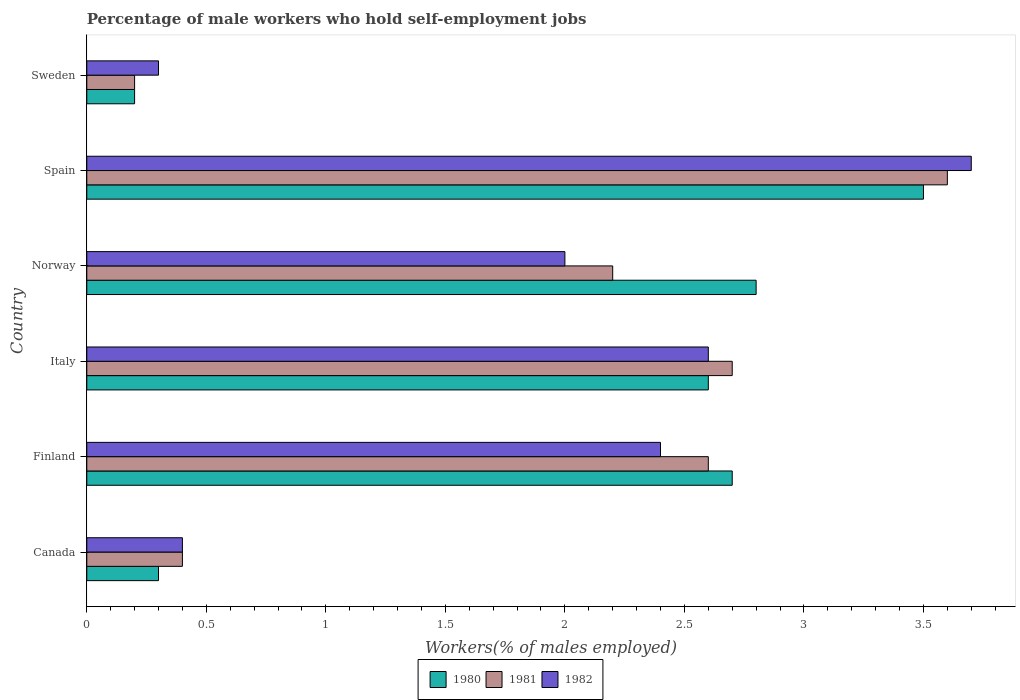How many different coloured bars are there?
Your answer should be compact. 3. How many groups of bars are there?
Give a very brief answer. 6. Are the number of bars per tick equal to the number of legend labels?
Your answer should be very brief. Yes. How many bars are there on the 5th tick from the top?
Make the answer very short. 3. How many bars are there on the 2nd tick from the bottom?
Make the answer very short. 3. In how many cases, is the number of bars for a given country not equal to the number of legend labels?
Provide a succinct answer. 0. What is the percentage of self-employed male workers in 1981 in Norway?
Make the answer very short. 2.2. Across all countries, what is the minimum percentage of self-employed male workers in 1982?
Offer a very short reply. 0.3. In which country was the percentage of self-employed male workers in 1981 maximum?
Give a very brief answer. Spain. What is the total percentage of self-employed male workers in 1981 in the graph?
Ensure brevity in your answer.  11.7. What is the difference between the percentage of self-employed male workers in 1980 in Finland and that in Italy?
Your response must be concise. 0.1. What is the difference between the percentage of self-employed male workers in 1980 in Spain and the percentage of self-employed male workers in 1981 in Finland?
Give a very brief answer. 0.9. What is the average percentage of self-employed male workers in 1982 per country?
Ensure brevity in your answer.  1.9. What is the ratio of the percentage of self-employed male workers in 1980 in Italy to that in Spain?
Keep it short and to the point. 0.74. Is the percentage of self-employed male workers in 1982 in Canada less than that in Sweden?
Offer a very short reply. No. What is the difference between the highest and the second highest percentage of self-employed male workers in 1981?
Your answer should be compact. 0.9. What is the difference between the highest and the lowest percentage of self-employed male workers in 1980?
Provide a succinct answer. 3.3. In how many countries, is the percentage of self-employed male workers in 1981 greater than the average percentage of self-employed male workers in 1981 taken over all countries?
Provide a succinct answer. 4. Is the sum of the percentage of self-employed male workers in 1982 in Spain and Sweden greater than the maximum percentage of self-employed male workers in 1980 across all countries?
Provide a succinct answer. Yes. What does the 3rd bar from the top in Canada represents?
Your answer should be very brief. 1980. What does the 3rd bar from the bottom in Italy represents?
Your answer should be compact. 1982. Is it the case that in every country, the sum of the percentage of self-employed male workers in 1980 and percentage of self-employed male workers in 1981 is greater than the percentage of self-employed male workers in 1982?
Make the answer very short. Yes. How many bars are there?
Offer a very short reply. 18. Does the graph contain grids?
Your answer should be compact. No. How are the legend labels stacked?
Make the answer very short. Horizontal. What is the title of the graph?
Provide a short and direct response. Percentage of male workers who hold self-employment jobs. What is the label or title of the X-axis?
Provide a short and direct response. Workers(% of males employed). What is the Workers(% of males employed) in 1980 in Canada?
Your response must be concise. 0.3. What is the Workers(% of males employed) in 1981 in Canada?
Keep it short and to the point. 0.4. What is the Workers(% of males employed) in 1982 in Canada?
Make the answer very short. 0.4. What is the Workers(% of males employed) of 1980 in Finland?
Keep it short and to the point. 2.7. What is the Workers(% of males employed) of 1981 in Finland?
Your answer should be very brief. 2.6. What is the Workers(% of males employed) in 1982 in Finland?
Ensure brevity in your answer.  2.4. What is the Workers(% of males employed) in 1980 in Italy?
Offer a terse response. 2.6. What is the Workers(% of males employed) in 1981 in Italy?
Your response must be concise. 2.7. What is the Workers(% of males employed) in 1982 in Italy?
Offer a very short reply. 2.6. What is the Workers(% of males employed) in 1980 in Norway?
Provide a succinct answer. 2.8. What is the Workers(% of males employed) of 1981 in Norway?
Offer a terse response. 2.2. What is the Workers(% of males employed) of 1981 in Spain?
Keep it short and to the point. 3.6. What is the Workers(% of males employed) in 1982 in Spain?
Make the answer very short. 3.7. What is the Workers(% of males employed) in 1980 in Sweden?
Offer a terse response. 0.2. What is the Workers(% of males employed) of 1981 in Sweden?
Ensure brevity in your answer.  0.2. What is the Workers(% of males employed) of 1982 in Sweden?
Your answer should be very brief. 0.3. Across all countries, what is the maximum Workers(% of males employed) in 1981?
Provide a short and direct response. 3.6. Across all countries, what is the maximum Workers(% of males employed) in 1982?
Your response must be concise. 3.7. Across all countries, what is the minimum Workers(% of males employed) of 1980?
Your answer should be compact. 0.2. Across all countries, what is the minimum Workers(% of males employed) of 1981?
Make the answer very short. 0.2. Across all countries, what is the minimum Workers(% of males employed) in 1982?
Provide a short and direct response. 0.3. What is the total Workers(% of males employed) in 1980 in the graph?
Offer a terse response. 12.1. What is the difference between the Workers(% of males employed) of 1981 in Canada and that in Finland?
Your response must be concise. -2.2. What is the difference between the Workers(% of males employed) of 1981 in Canada and that in Norway?
Your response must be concise. -1.8. What is the difference between the Workers(% of males employed) of 1982 in Canada and that in Norway?
Keep it short and to the point. -1.6. What is the difference between the Workers(% of males employed) of 1980 in Canada and that in Spain?
Ensure brevity in your answer.  -3.2. What is the difference between the Workers(% of males employed) in 1981 in Canada and that in Spain?
Your response must be concise. -3.2. What is the difference between the Workers(% of males employed) of 1982 in Canada and that in Spain?
Ensure brevity in your answer.  -3.3. What is the difference between the Workers(% of males employed) of 1980 in Canada and that in Sweden?
Your answer should be very brief. 0.1. What is the difference between the Workers(% of males employed) of 1982 in Canada and that in Sweden?
Offer a terse response. 0.1. What is the difference between the Workers(% of males employed) of 1980 in Finland and that in Norway?
Your response must be concise. -0.1. What is the difference between the Workers(% of males employed) of 1981 in Finland and that in Norway?
Your answer should be compact. 0.4. What is the difference between the Workers(% of males employed) of 1980 in Finland and that in Spain?
Offer a terse response. -0.8. What is the difference between the Workers(% of males employed) in 1982 in Finland and that in Spain?
Provide a short and direct response. -1.3. What is the difference between the Workers(% of males employed) in 1980 in Finland and that in Sweden?
Make the answer very short. 2.5. What is the difference between the Workers(% of males employed) in 1981 in Finland and that in Sweden?
Your answer should be very brief. 2.4. What is the difference between the Workers(% of males employed) of 1981 in Italy and that in Norway?
Offer a terse response. 0.5. What is the difference between the Workers(% of males employed) of 1982 in Italy and that in Spain?
Ensure brevity in your answer.  -1.1. What is the difference between the Workers(% of males employed) of 1980 in Italy and that in Sweden?
Ensure brevity in your answer.  2.4. What is the difference between the Workers(% of males employed) of 1982 in Italy and that in Sweden?
Your answer should be very brief. 2.3. What is the difference between the Workers(% of males employed) in 1980 in Norway and that in Spain?
Give a very brief answer. -0.7. What is the difference between the Workers(% of males employed) in 1981 in Norway and that in Spain?
Your response must be concise. -1.4. What is the difference between the Workers(% of males employed) of 1980 in Norway and that in Sweden?
Offer a terse response. 2.6. What is the difference between the Workers(% of males employed) in 1982 in Norway and that in Sweden?
Offer a terse response. 1.7. What is the difference between the Workers(% of males employed) in 1980 in Spain and that in Sweden?
Keep it short and to the point. 3.3. What is the difference between the Workers(% of males employed) in 1981 in Spain and that in Sweden?
Provide a short and direct response. 3.4. What is the difference between the Workers(% of males employed) of 1980 in Canada and the Workers(% of males employed) of 1981 in Finland?
Your answer should be very brief. -2.3. What is the difference between the Workers(% of males employed) of 1981 in Canada and the Workers(% of males employed) of 1982 in Finland?
Keep it short and to the point. -2. What is the difference between the Workers(% of males employed) of 1981 in Canada and the Workers(% of males employed) of 1982 in Italy?
Offer a very short reply. -2.2. What is the difference between the Workers(% of males employed) of 1980 in Canada and the Workers(% of males employed) of 1981 in Norway?
Your response must be concise. -1.9. What is the difference between the Workers(% of males employed) in 1980 in Canada and the Workers(% of males employed) in 1982 in Norway?
Make the answer very short. -1.7. What is the difference between the Workers(% of males employed) of 1981 in Canada and the Workers(% of males employed) of 1982 in Norway?
Offer a terse response. -1.6. What is the difference between the Workers(% of males employed) of 1980 in Canada and the Workers(% of males employed) of 1981 in Spain?
Ensure brevity in your answer.  -3.3. What is the difference between the Workers(% of males employed) in 1980 in Finland and the Workers(% of males employed) in 1981 in Italy?
Provide a succinct answer. 0. What is the difference between the Workers(% of males employed) of 1981 in Finland and the Workers(% of males employed) of 1982 in Italy?
Ensure brevity in your answer.  0. What is the difference between the Workers(% of males employed) in 1980 in Finland and the Workers(% of males employed) in 1981 in Spain?
Offer a very short reply. -0.9. What is the difference between the Workers(% of males employed) in 1980 in Finland and the Workers(% of males employed) in 1982 in Spain?
Your answer should be very brief. -1. What is the difference between the Workers(% of males employed) in 1981 in Finland and the Workers(% of males employed) in 1982 in Spain?
Your answer should be compact. -1.1. What is the difference between the Workers(% of males employed) of 1980 in Finland and the Workers(% of males employed) of 1981 in Sweden?
Keep it short and to the point. 2.5. What is the difference between the Workers(% of males employed) of 1980 in Italy and the Workers(% of males employed) of 1981 in Spain?
Offer a very short reply. -1. What is the difference between the Workers(% of males employed) in 1980 in Italy and the Workers(% of males employed) in 1982 in Spain?
Ensure brevity in your answer.  -1.1. What is the difference between the Workers(% of males employed) in 1980 in Italy and the Workers(% of males employed) in 1982 in Sweden?
Provide a short and direct response. 2.3. What is the difference between the Workers(% of males employed) in 1981 in Italy and the Workers(% of males employed) in 1982 in Sweden?
Offer a very short reply. 2.4. What is the difference between the Workers(% of males employed) in 1981 in Norway and the Workers(% of males employed) in 1982 in Spain?
Ensure brevity in your answer.  -1.5. What is the difference between the Workers(% of males employed) of 1980 in Norway and the Workers(% of males employed) of 1981 in Sweden?
Provide a succinct answer. 2.6. What is the difference between the Workers(% of males employed) of 1981 in Norway and the Workers(% of males employed) of 1982 in Sweden?
Your answer should be compact. 1.9. What is the difference between the Workers(% of males employed) of 1980 in Spain and the Workers(% of males employed) of 1981 in Sweden?
Your answer should be compact. 3.3. What is the average Workers(% of males employed) of 1980 per country?
Offer a very short reply. 2.02. What is the average Workers(% of males employed) in 1981 per country?
Keep it short and to the point. 1.95. What is the difference between the Workers(% of males employed) of 1980 and Workers(% of males employed) of 1982 in Canada?
Offer a very short reply. -0.1. What is the difference between the Workers(% of males employed) in 1981 and Workers(% of males employed) in 1982 in Canada?
Make the answer very short. 0. What is the difference between the Workers(% of males employed) in 1981 and Workers(% of males employed) in 1982 in Finland?
Offer a very short reply. 0.2. What is the difference between the Workers(% of males employed) in 1980 and Workers(% of males employed) in 1982 in Italy?
Your answer should be compact. 0. What is the difference between the Workers(% of males employed) of 1980 and Workers(% of males employed) of 1981 in Norway?
Your answer should be compact. 0.6. What is the difference between the Workers(% of males employed) in 1980 and Workers(% of males employed) in 1982 in Norway?
Offer a terse response. 0.8. What is the difference between the Workers(% of males employed) in 1980 and Workers(% of males employed) in 1981 in Spain?
Keep it short and to the point. -0.1. What is the difference between the Workers(% of males employed) in 1980 and Workers(% of males employed) in 1982 in Sweden?
Ensure brevity in your answer.  -0.1. What is the difference between the Workers(% of males employed) of 1981 and Workers(% of males employed) of 1982 in Sweden?
Offer a very short reply. -0.1. What is the ratio of the Workers(% of males employed) of 1981 in Canada to that in Finland?
Your answer should be very brief. 0.15. What is the ratio of the Workers(% of males employed) of 1980 in Canada to that in Italy?
Keep it short and to the point. 0.12. What is the ratio of the Workers(% of males employed) of 1981 in Canada to that in Italy?
Your answer should be compact. 0.15. What is the ratio of the Workers(% of males employed) of 1982 in Canada to that in Italy?
Provide a short and direct response. 0.15. What is the ratio of the Workers(% of males employed) of 1980 in Canada to that in Norway?
Provide a short and direct response. 0.11. What is the ratio of the Workers(% of males employed) of 1981 in Canada to that in Norway?
Your answer should be very brief. 0.18. What is the ratio of the Workers(% of males employed) of 1980 in Canada to that in Spain?
Your response must be concise. 0.09. What is the ratio of the Workers(% of males employed) of 1981 in Canada to that in Spain?
Make the answer very short. 0.11. What is the ratio of the Workers(% of males employed) of 1982 in Canada to that in Spain?
Provide a short and direct response. 0.11. What is the ratio of the Workers(% of males employed) of 1981 in Canada to that in Sweden?
Provide a short and direct response. 2. What is the ratio of the Workers(% of males employed) in 1982 in Canada to that in Sweden?
Make the answer very short. 1.33. What is the ratio of the Workers(% of males employed) of 1982 in Finland to that in Italy?
Offer a terse response. 0.92. What is the ratio of the Workers(% of males employed) in 1980 in Finland to that in Norway?
Provide a short and direct response. 0.96. What is the ratio of the Workers(% of males employed) in 1981 in Finland to that in Norway?
Your response must be concise. 1.18. What is the ratio of the Workers(% of males employed) in 1982 in Finland to that in Norway?
Your response must be concise. 1.2. What is the ratio of the Workers(% of males employed) of 1980 in Finland to that in Spain?
Offer a very short reply. 0.77. What is the ratio of the Workers(% of males employed) in 1981 in Finland to that in Spain?
Your response must be concise. 0.72. What is the ratio of the Workers(% of males employed) of 1982 in Finland to that in Spain?
Make the answer very short. 0.65. What is the ratio of the Workers(% of males employed) in 1980 in Finland to that in Sweden?
Ensure brevity in your answer.  13.5. What is the ratio of the Workers(% of males employed) of 1982 in Finland to that in Sweden?
Your response must be concise. 8. What is the ratio of the Workers(% of males employed) of 1981 in Italy to that in Norway?
Your answer should be compact. 1.23. What is the ratio of the Workers(% of males employed) of 1982 in Italy to that in Norway?
Keep it short and to the point. 1.3. What is the ratio of the Workers(% of males employed) in 1980 in Italy to that in Spain?
Make the answer very short. 0.74. What is the ratio of the Workers(% of males employed) in 1981 in Italy to that in Spain?
Ensure brevity in your answer.  0.75. What is the ratio of the Workers(% of males employed) of 1982 in Italy to that in Spain?
Give a very brief answer. 0.7. What is the ratio of the Workers(% of males employed) in 1980 in Italy to that in Sweden?
Offer a terse response. 13. What is the ratio of the Workers(% of males employed) in 1982 in Italy to that in Sweden?
Offer a very short reply. 8.67. What is the ratio of the Workers(% of males employed) in 1980 in Norway to that in Spain?
Offer a very short reply. 0.8. What is the ratio of the Workers(% of males employed) of 1981 in Norway to that in Spain?
Ensure brevity in your answer.  0.61. What is the ratio of the Workers(% of males employed) of 1982 in Norway to that in Spain?
Give a very brief answer. 0.54. What is the ratio of the Workers(% of males employed) of 1980 in Norway to that in Sweden?
Your response must be concise. 14. What is the ratio of the Workers(% of males employed) of 1982 in Norway to that in Sweden?
Your answer should be compact. 6.67. What is the ratio of the Workers(% of males employed) of 1981 in Spain to that in Sweden?
Make the answer very short. 18. What is the ratio of the Workers(% of males employed) of 1982 in Spain to that in Sweden?
Offer a very short reply. 12.33. What is the difference between the highest and the second highest Workers(% of males employed) of 1980?
Offer a very short reply. 0.7. What is the difference between the highest and the second highest Workers(% of males employed) in 1981?
Your answer should be compact. 0.9. What is the difference between the highest and the second highest Workers(% of males employed) of 1982?
Provide a short and direct response. 1.1. What is the difference between the highest and the lowest Workers(% of males employed) in 1980?
Ensure brevity in your answer.  3.3. 